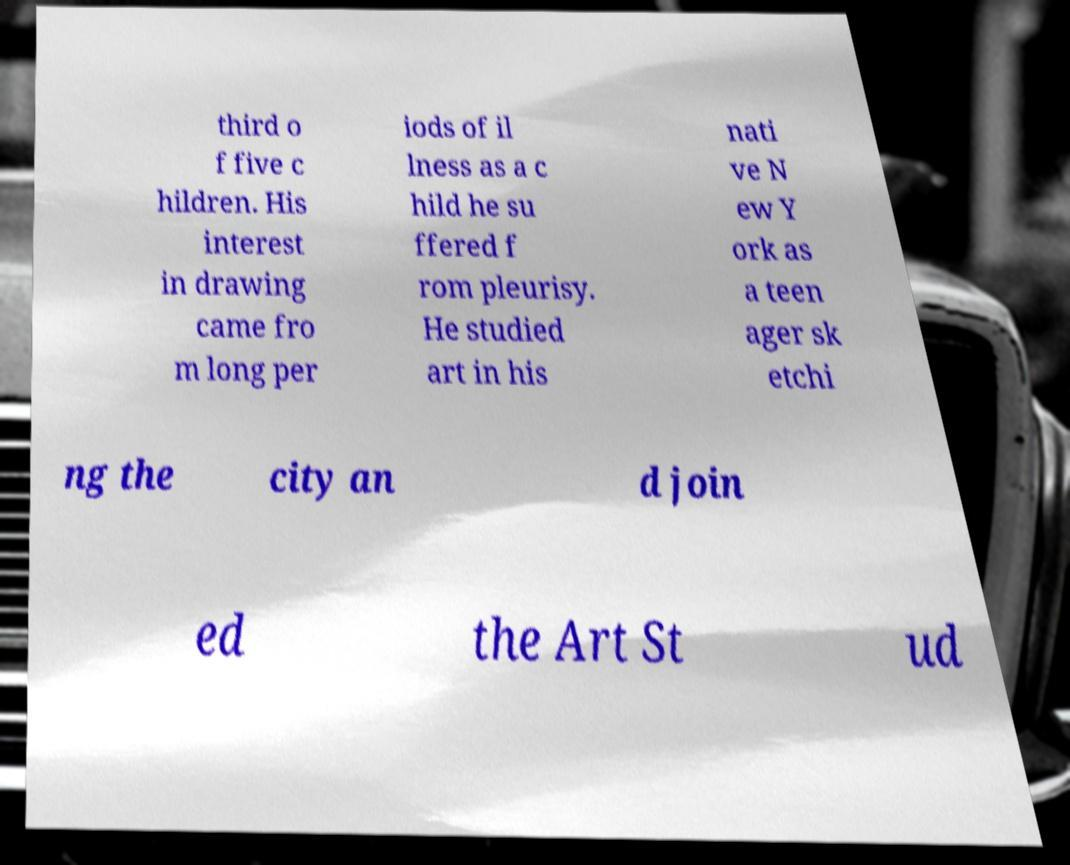Could you assist in decoding the text presented in this image and type it out clearly? third o f five c hildren. His interest in drawing came fro m long per iods of il lness as a c hild he su ffered f rom pleurisy. He studied art in his nati ve N ew Y ork as a teen ager sk etchi ng the city an d join ed the Art St ud 